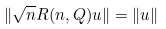Convert formula to latex. <formula><loc_0><loc_0><loc_500><loc_500>\| \sqrt { n } R ( n , Q ) u \| = \| u \|</formula> 